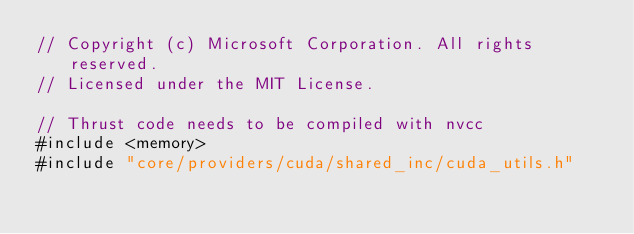Convert code to text. <code><loc_0><loc_0><loc_500><loc_500><_Cuda_>// Copyright (c) Microsoft Corporation. All rights reserved.
// Licensed under the MIT License.

// Thrust code needs to be compiled with nvcc
#include <memory>
#include "core/providers/cuda/shared_inc/cuda_utils.h"</code> 